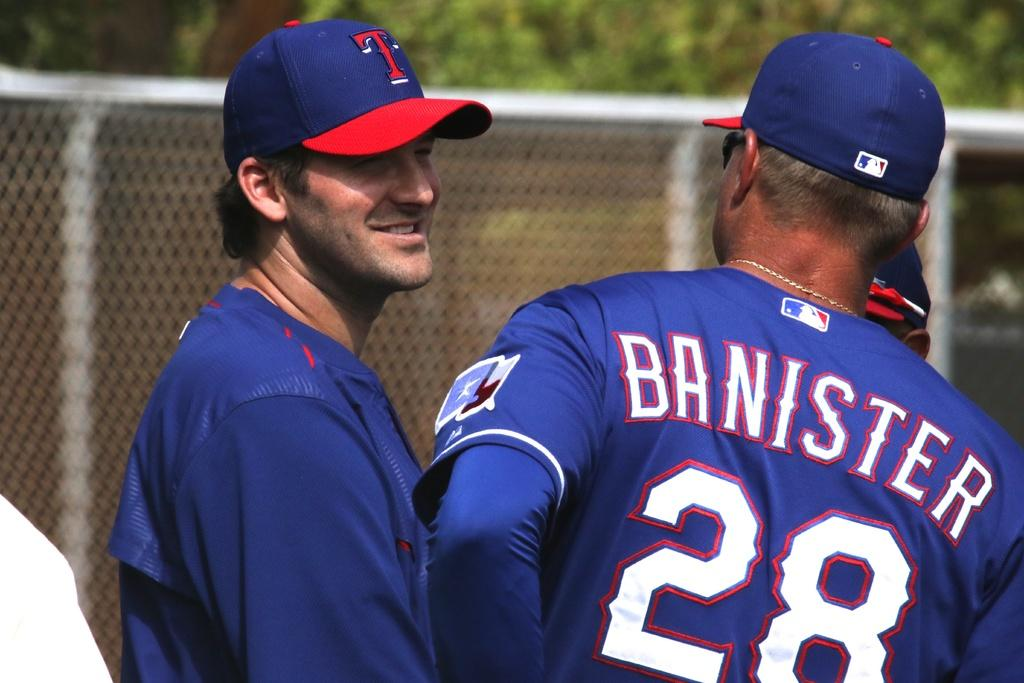<image>
Share a concise interpretation of the image provided. Texas Rangers head coach Jeff Banister talking to Tony Romo 